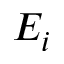<formula> <loc_0><loc_0><loc_500><loc_500>E _ { i }</formula> 